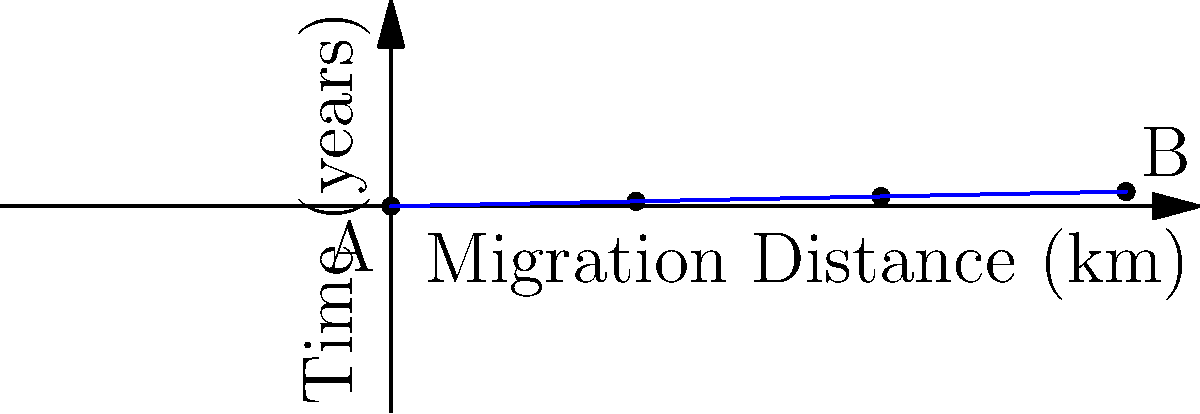In an anthropological study of migration patterns, researchers plotted the distance traveled by a nomadic group over time. The graph shows two points: A (0, 0) representing the starting point, and B (3000, 60) representing their location after 60 years. Calculate the slope of the line connecting these two points. What does this slope represent in the context of the nomadic group's migration? To solve this problem, we'll follow these steps:

1) Recall the slope formula: $m = \frac{y_2 - y_1}{x_2 - x_1}$

2) Identify the coordinates:
   Point A: $(x_1, y_1) = (0, 0)$
   Point B: $(x_2, y_2) = (3000, 60)$

3) Plug these values into the slope formula:

   $m = \frac{60 - 0}{3000 - 0} = \frac{60}{3000}$

4) Simplify:
   $m = \frac{1}{50} = 0.02$

5) Interpret the result:
   The slope represents the rate of change of y with respect to x. In this context:
   - y represents time in years
   - x represents distance traveled in kilometers

   Therefore, the slope (0.02 years/km) represents the time taken to travel one kilometer.

6) To make this more intuitive, we can take the reciprocal:
   $\frac{1}{0.02} = 50$ km/year

This means the nomadic group traveled an average of 50 kilometers per year over the 60-year period.
Answer: Slope = 0.02 years/km, representing an average migration rate of 50 km/year. 